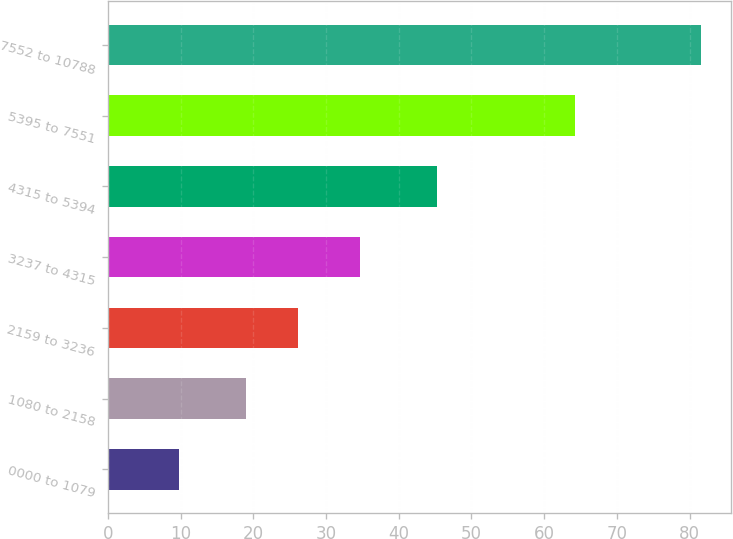<chart> <loc_0><loc_0><loc_500><loc_500><bar_chart><fcel>0000 to 1079<fcel>1080 to 2158<fcel>2159 to 3236<fcel>3237 to 4315<fcel>4315 to 5394<fcel>5395 to 7551<fcel>7552 to 10788<nl><fcel>9.81<fcel>19<fcel>26.18<fcel>34.72<fcel>45.28<fcel>64.27<fcel>81.64<nl></chart> 